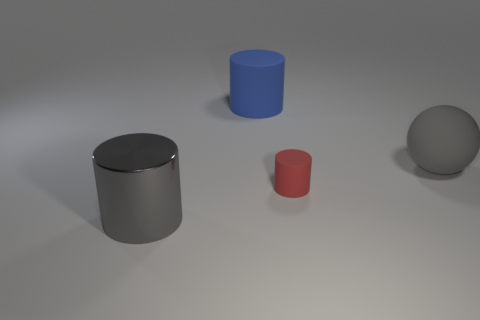Subtract all large cylinders. How many cylinders are left? 1 Add 2 small red shiny cylinders. How many objects exist? 6 Subtract all gray cylinders. How many cylinders are left? 2 Subtract all cylinders. How many objects are left? 1 Subtract all big matte cylinders. Subtract all tiny matte cylinders. How many objects are left? 2 Add 4 gray shiny things. How many gray shiny things are left? 5 Add 3 big gray shiny things. How many big gray shiny things exist? 4 Subtract 0 brown cylinders. How many objects are left? 4 Subtract all cyan cylinders. Subtract all brown cubes. How many cylinders are left? 3 Subtract all green cylinders. How many yellow balls are left? 0 